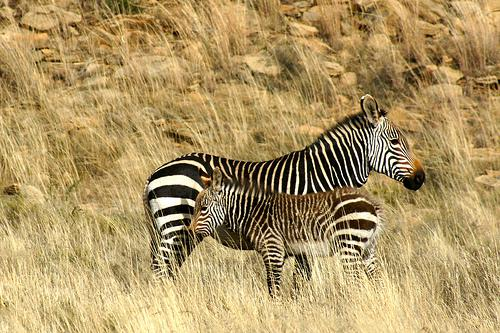Question: how is the photo?
Choices:
A. Bright.
B. Blurry.
C. Black and white.
D. Clear.
Answer with the letter. Answer: D Question: how are the zebras?
Choices:
A. Laying.
B. Standing.
C. Staring.
D. Eating.
Answer with the letter. Answer: B Question: what is on the ground?
Choices:
A. Snow.
B. Water.
C. Dirt.
D. Grass.
Answer with the letter. Answer: D Question: when is this?
Choices:
A. Daytime.
B. Last week.
C. Yesterday.
D. This morning.
Answer with the letter. Answer: A Question: where is this scene?
Choices:
A. In a field.
B. At park.
C. Zoo.
D. Street.
Answer with the letter. Answer: A 